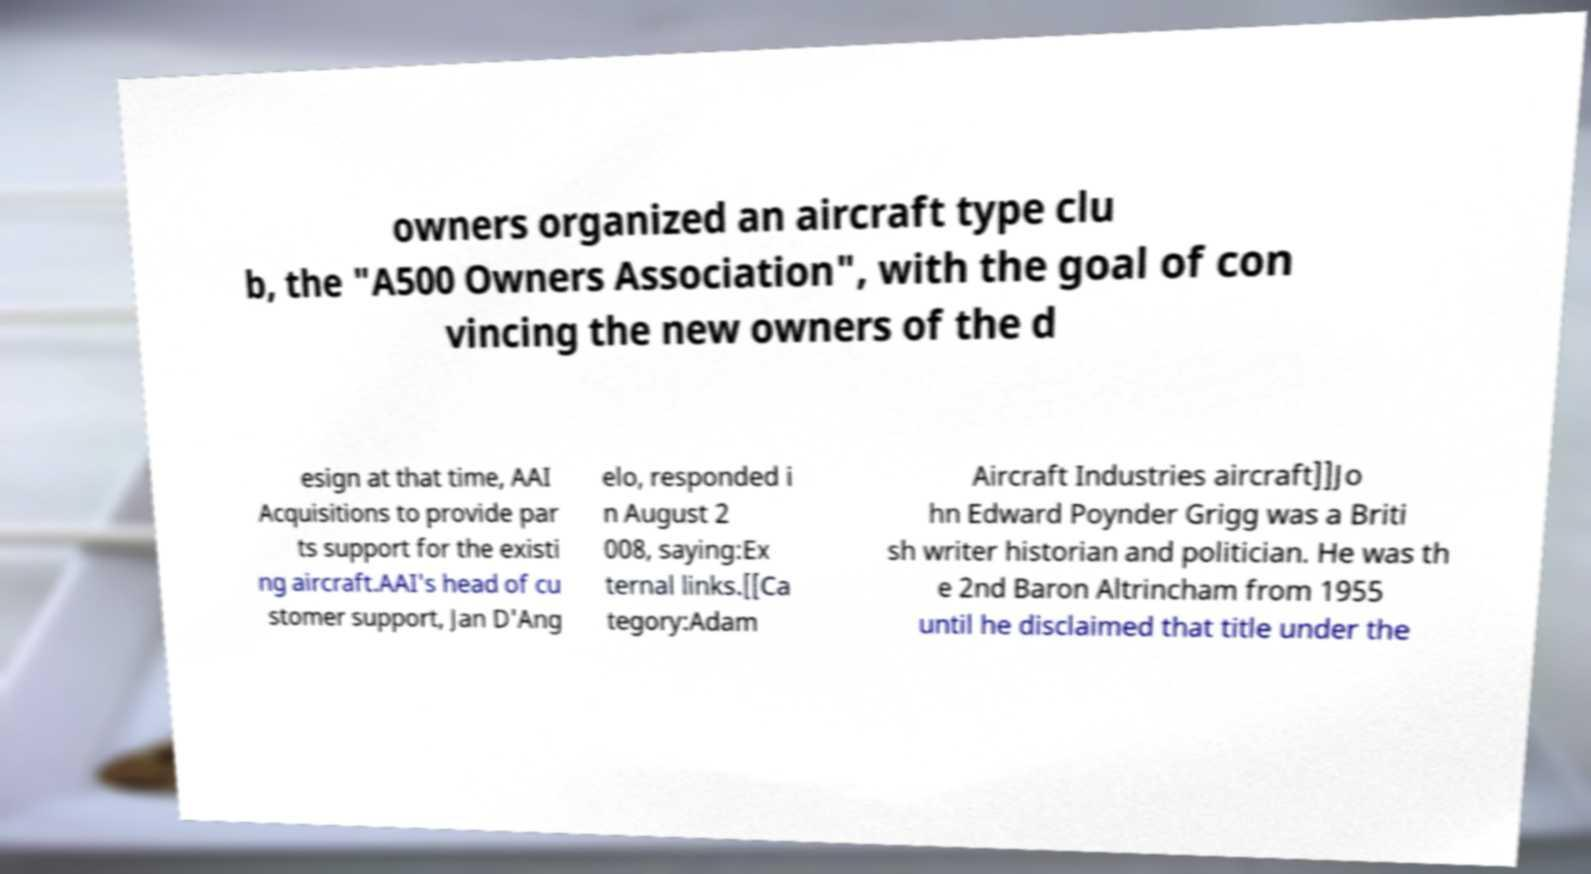Please identify and transcribe the text found in this image. owners organized an aircraft type clu b, the "A500 Owners Association", with the goal of con vincing the new owners of the d esign at that time, AAI Acquisitions to provide par ts support for the existi ng aircraft.AAI's head of cu stomer support, Jan D'Ang elo, responded i n August 2 008, saying:Ex ternal links.[[Ca tegory:Adam Aircraft Industries aircraft]]Jo hn Edward Poynder Grigg was a Briti sh writer historian and politician. He was th e 2nd Baron Altrincham from 1955 until he disclaimed that title under the 